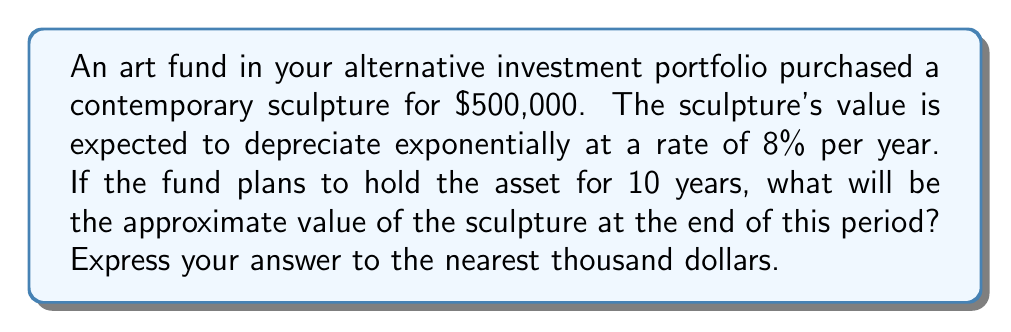Can you answer this question? To solve this problem, we'll use the exponential decay formula:

$$A = P(1-r)^t$$

Where:
$A$ = Final amount
$P$ = Initial principal (starting value)
$r$ = Annual rate of depreciation
$t$ = Time in years

Given:
$P = \$500,000$
$r = 8\% = 0.08$
$t = 10$ years

Step 1: Substitute the values into the formula:
$$A = 500,000(1-0.08)^{10}$$

Step 2: Simplify the expression inside the parentheses:
$$A = 500,000(0.92)^{10}$$

Step 3: Calculate the power:
$$A = 500,000 \times 0.4327$$

Step 4: Multiply:
$$A = 216,350$$

Step 5: Round to the nearest thousand:
$$A \approx 216,000$$

Therefore, the approximate value of the sculpture after 10 years will be $216,000.
Answer: $216,000 